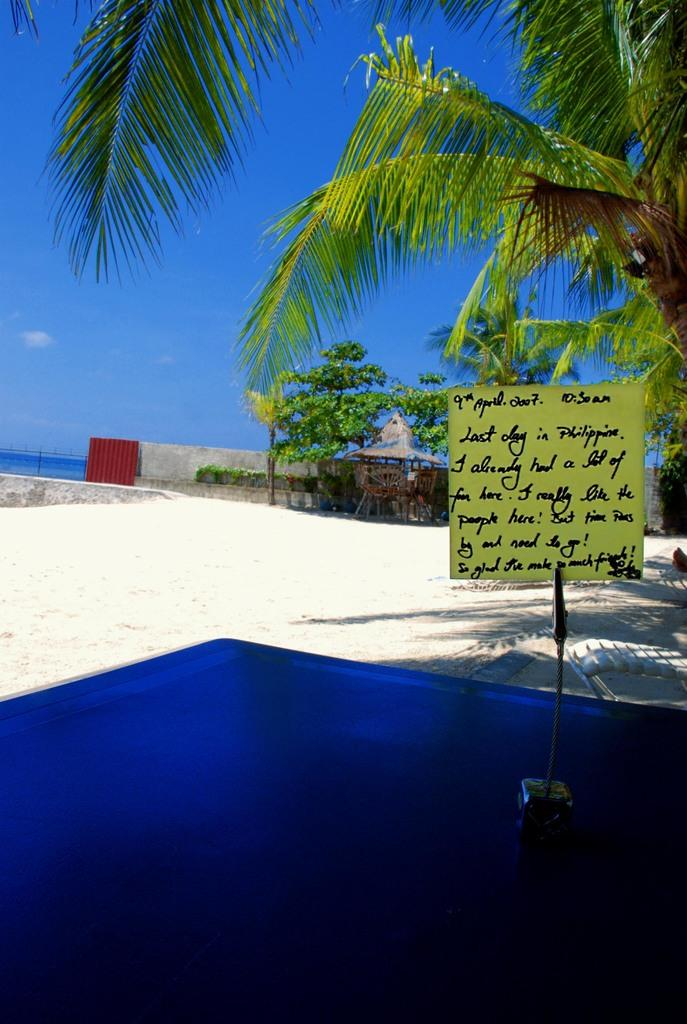What is the main piece of furniture in the image? There is a table in the image. What is placed on the table? A board is placed on the table. What type of structure can be seen in the image? There is a shed in the image. What type of vegetation is present in the image? Trees are present in the image. What architectural feature is visible in the image? There is a wall in the image. What is visible in the background of the image? The sky is visible in the background of the image. What word is written on the owl's feathers in the image? There is no owl present in the image, and therefore no words can be found on its feathers. 